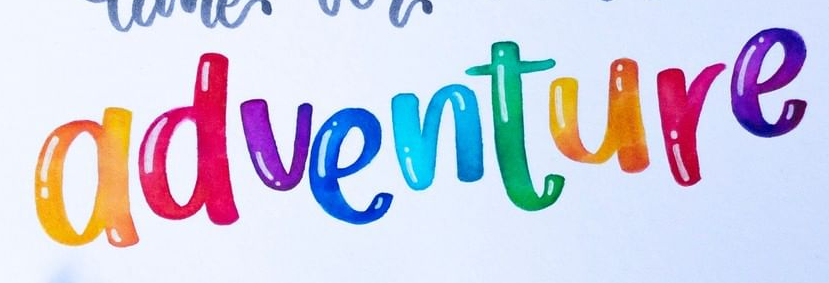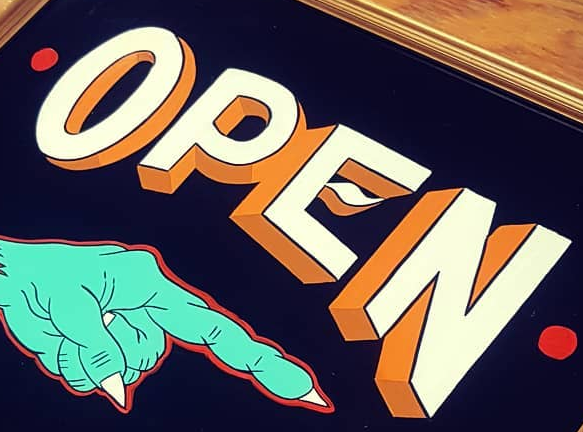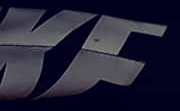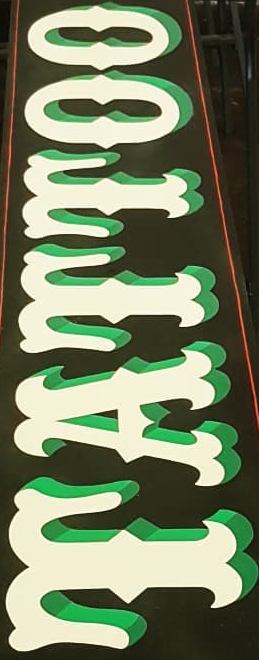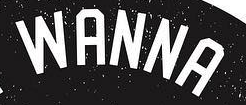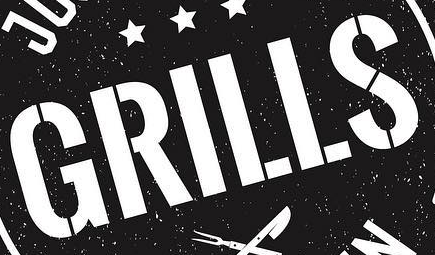Identify the words shown in these images in order, separated by a semicolon. adventure; OPEN; KF; TATTOO; WANNA; GRILLS 